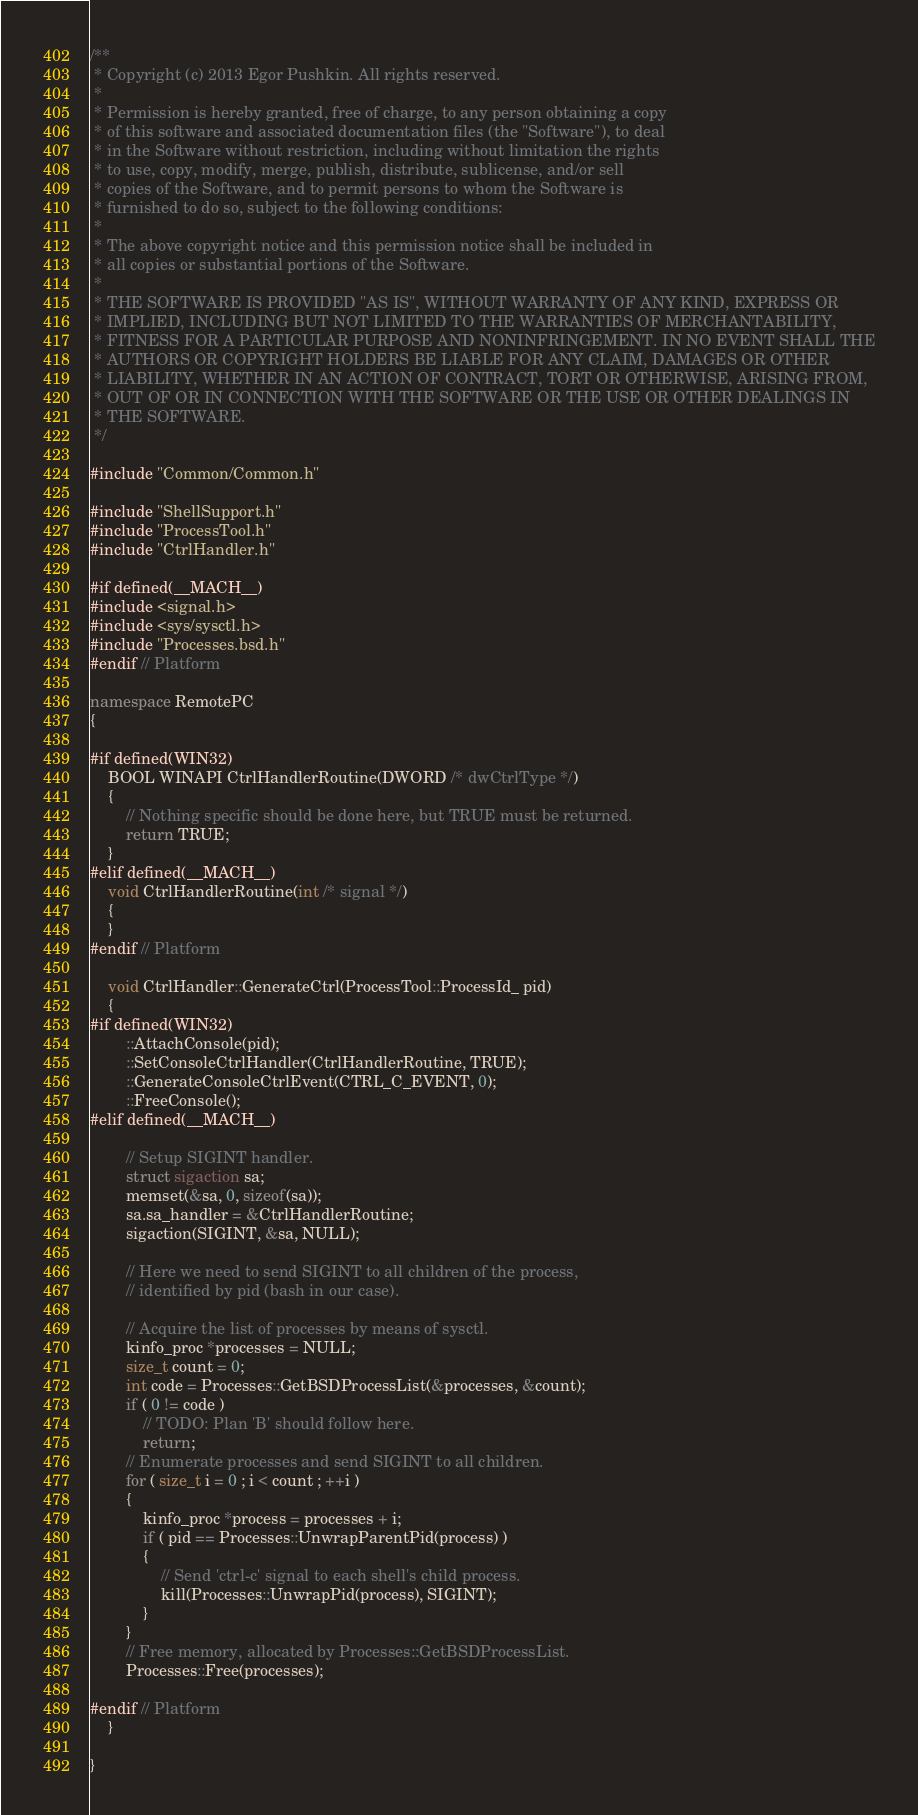Convert code to text. <code><loc_0><loc_0><loc_500><loc_500><_C++_>/**
 * Copyright (c) 2013 Egor Pushkin. All rights reserved.
 * 
 * Permission is hereby granted, free of charge, to any person obtaining a copy
 * of this software and associated documentation files (the "Software"), to deal
 * in the Software without restriction, including without limitation the rights
 * to use, copy, modify, merge, publish, distribute, sublicense, and/or sell
 * copies of the Software, and to permit persons to whom the Software is
 * furnished to do so, subject to the following conditions:
 * 
 * The above copyright notice and this permission notice shall be included in
 * all copies or substantial portions of the Software.
 * 
 * THE SOFTWARE IS PROVIDED "AS IS", WITHOUT WARRANTY OF ANY KIND, EXPRESS OR
 * IMPLIED, INCLUDING BUT NOT LIMITED TO THE WARRANTIES OF MERCHANTABILITY,
 * FITNESS FOR A PARTICULAR PURPOSE AND NONINFRINGEMENT. IN NO EVENT SHALL THE
 * AUTHORS OR COPYRIGHT HOLDERS BE LIABLE FOR ANY CLAIM, DAMAGES OR OTHER
 * LIABILITY, WHETHER IN AN ACTION OF CONTRACT, TORT OR OTHERWISE, ARISING FROM,
 * OUT OF OR IN CONNECTION WITH THE SOFTWARE OR THE USE OR OTHER DEALINGS IN
 * THE SOFTWARE.
 */

#include "Common/Common.h"

#include "ShellSupport.h"
#include "ProcessTool.h"
#include "CtrlHandler.h"

#if defined(__MACH__)
#include <signal.h>
#include <sys/sysctl.h>
#include "Processes.bsd.h"
#endif // Platform

namespace RemotePC
{

#if defined(WIN32)
	BOOL WINAPI CtrlHandlerRoutine(DWORD /* dwCtrlType */)
	{
		// Nothing specific should be done here, but TRUE must be returned.
		return TRUE;
	}
#elif defined(__MACH__)
	void CtrlHandlerRoutine(int /* signal */)
	{
	}
#endif // Platform

	void CtrlHandler::GenerateCtrl(ProcessTool::ProcessId_ pid)
	{
#if defined(WIN32)
		::AttachConsole(pid);
		::SetConsoleCtrlHandler(CtrlHandlerRoutine, TRUE);
		::GenerateConsoleCtrlEvent(CTRL_C_EVENT, 0);
		::FreeConsole();
#elif defined(__MACH__)

		// Setup SIGINT handler.
		struct sigaction sa;
		memset(&sa, 0, sizeof(sa));
		sa.sa_handler = &CtrlHandlerRoutine;
		sigaction(SIGINT, &sa, NULL);

		// Here we need to send SIGINT to all children of the process,
		// identified by pid (bash in our case).

		// Acquire the list of processes by means of sysctl.
		kinfo_proc *processes = NULL;
		size_t count = 0;
		int code = Processes::GetBSDProcessList(&processes, &count);
		if ( 0 != code )
			// TODO: Plan 'B' should follow here.
			return;
		// Enumerate processes and send SIGINT to all children.
		for ( size_t i = 0 ; i < count ; ++i )
		{
			kinfo_proc *process = processes + i;
			if ( pid == Processes::UnwrapParentPid(process) )
			{
				// Send 'ctrl-c' signal to each shell's child process.
                kill(Processes::UnwrapPid(process), SIGINT);
			}
		}
		// Free memory, allocated by Processes::GetBSDProcessList.
		Processes::Free(processes);

#endif // Platform
	}

}
</code> 